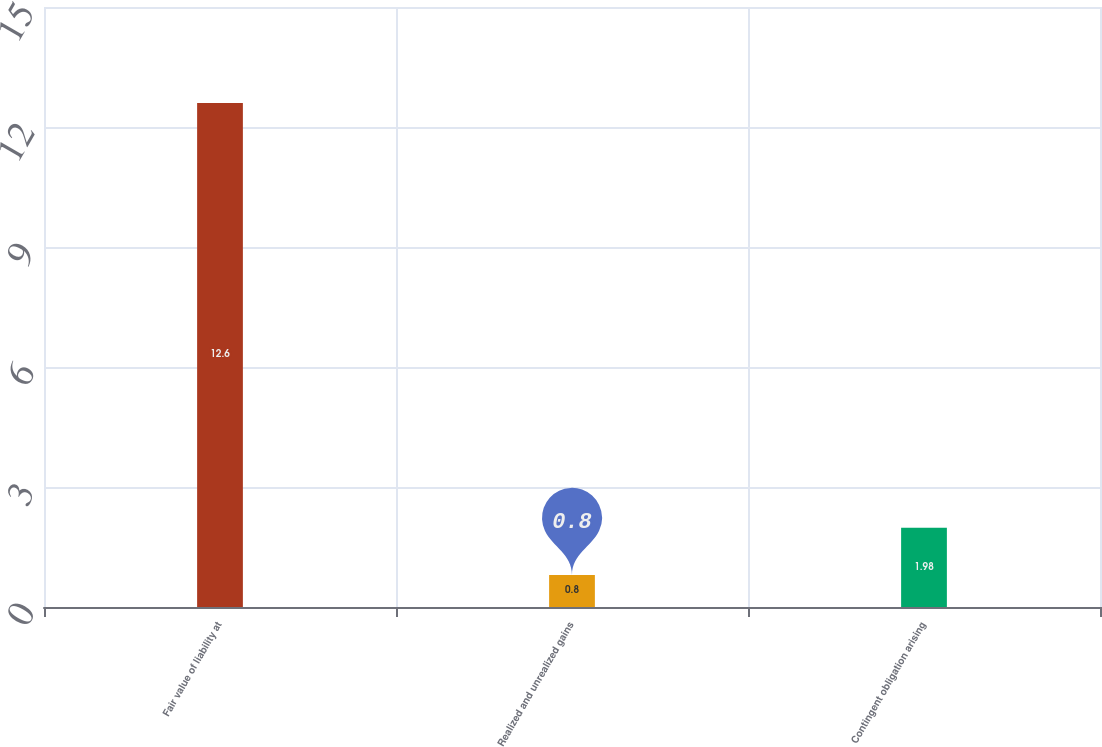Convert chart to OTSL. <chart><loc_0><loc_0><loc_500><loc_500><bar_chart><fcel>Fair value of liability at<fcel>Realized and unrealized gains<fcel>Contingent obligation arising<nl><fcel>12.6<fcel>0.8<fcel>1.98<nl></chart> 